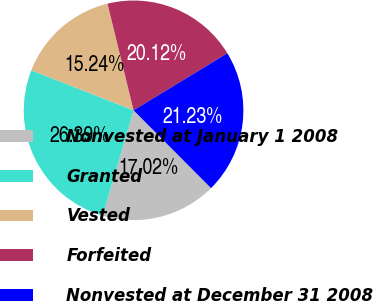Convert chart to OTSL. <chart><loc_0><loc_0><loc_500><loc_500><pie_chart><fcel>Nonvested at January 1 2008<fcel>Granted<fcel>Vested<fcel>Forfeited<fcel>Nonvested at December 31 2008<nl><fcel>17.02%<fcel>26.39%<fcel>15.24%<fcel>20.12%<fcel>21.23%<nl></chart> 